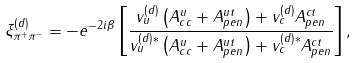Convert formula to latex. <formula><loc_0><loc_0><loc_500><loc_500>\xi ^ { ( d ) } _ { \pi ^ { + } \pi ^ { - } } = - e ^ { - 2 i \beta } \left [ \frac { v _ { u } ^ { ( d ) } \left ( A _ { c c } ^ { u } + A ^ { u t } _ { p e n } \right ) + v _ { c } ^ { ( d ) } A ^ { c t } _ { p e n } } { v _ { u } ^ { ( d ) \ast } \left ( A _ { c c } ^ { u } + A ^ { u t } _ { p e n } \right ) + v _ { c } ^ { ( d ) \ast } A ^ { c t } _ { p e n } } \right ] ,</formula> 